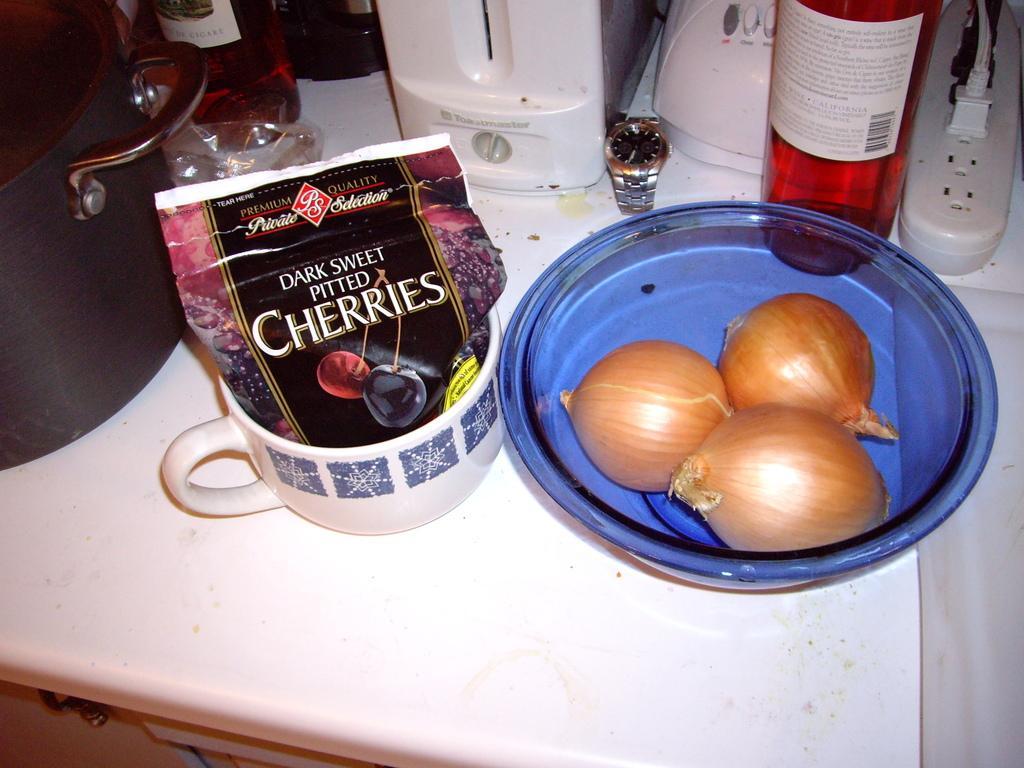Please provide a concise description of this image. On the table we can see three onions in a bowl,wine bottles,electronic devices,connect box,a packet in a cup,watch,electronic devices,vessel and some other items. 